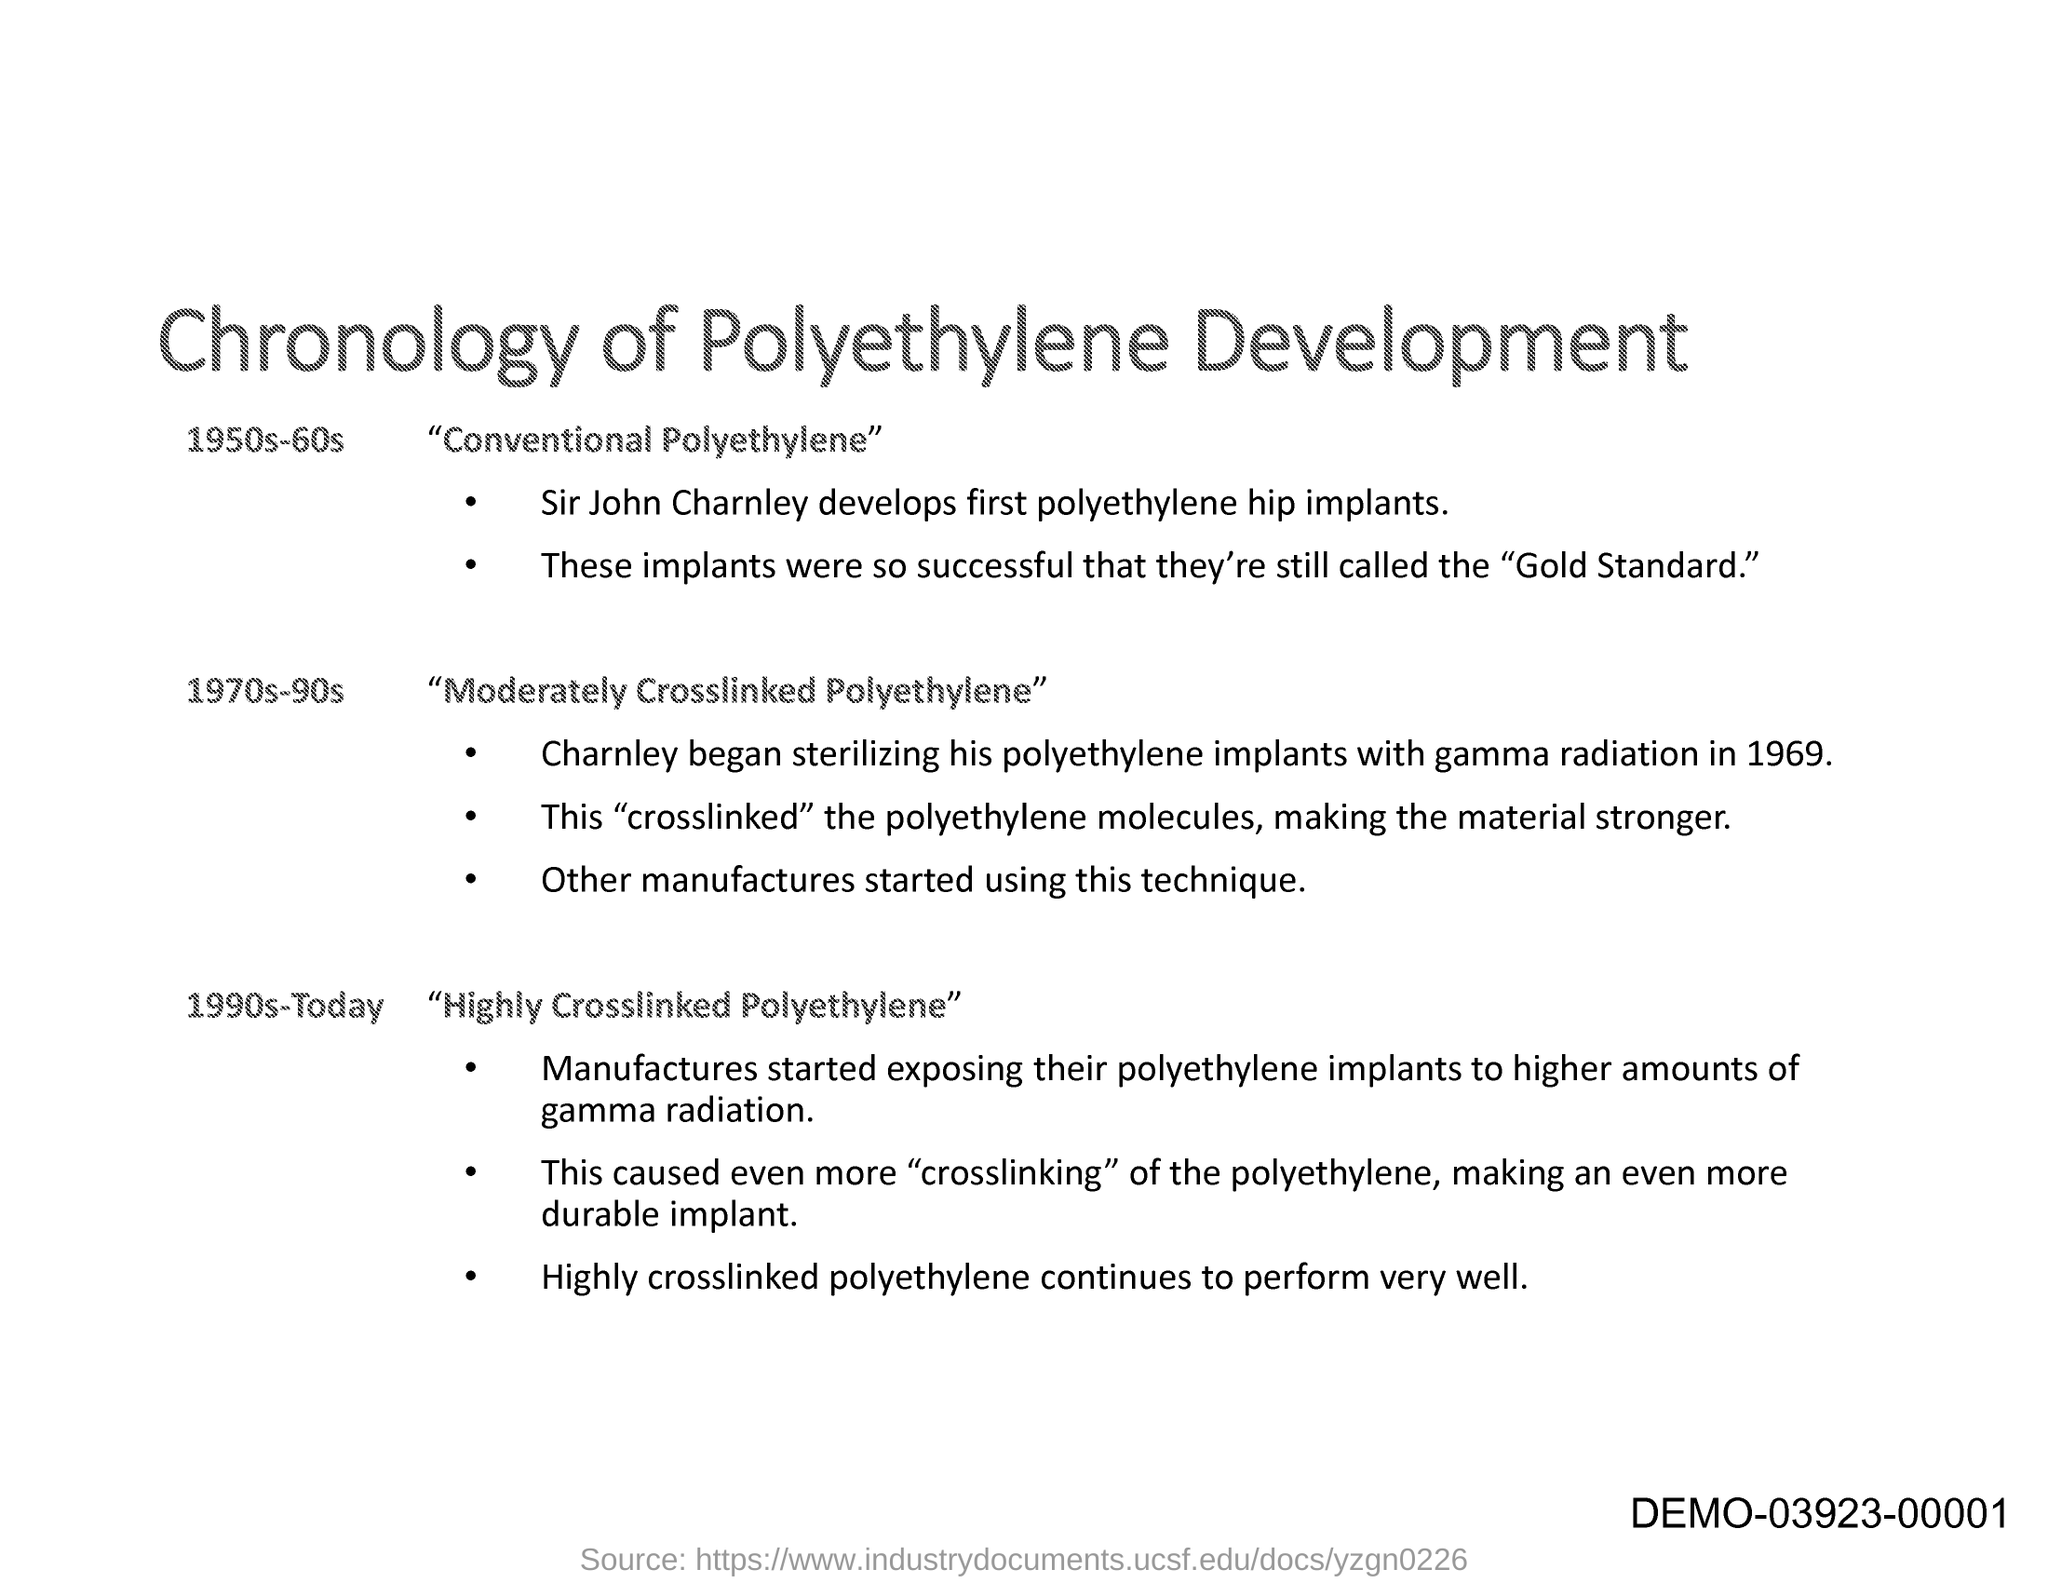Highlight a few significant elements in this photo. The title of this document is "Chronology of Polyethylene Development. 